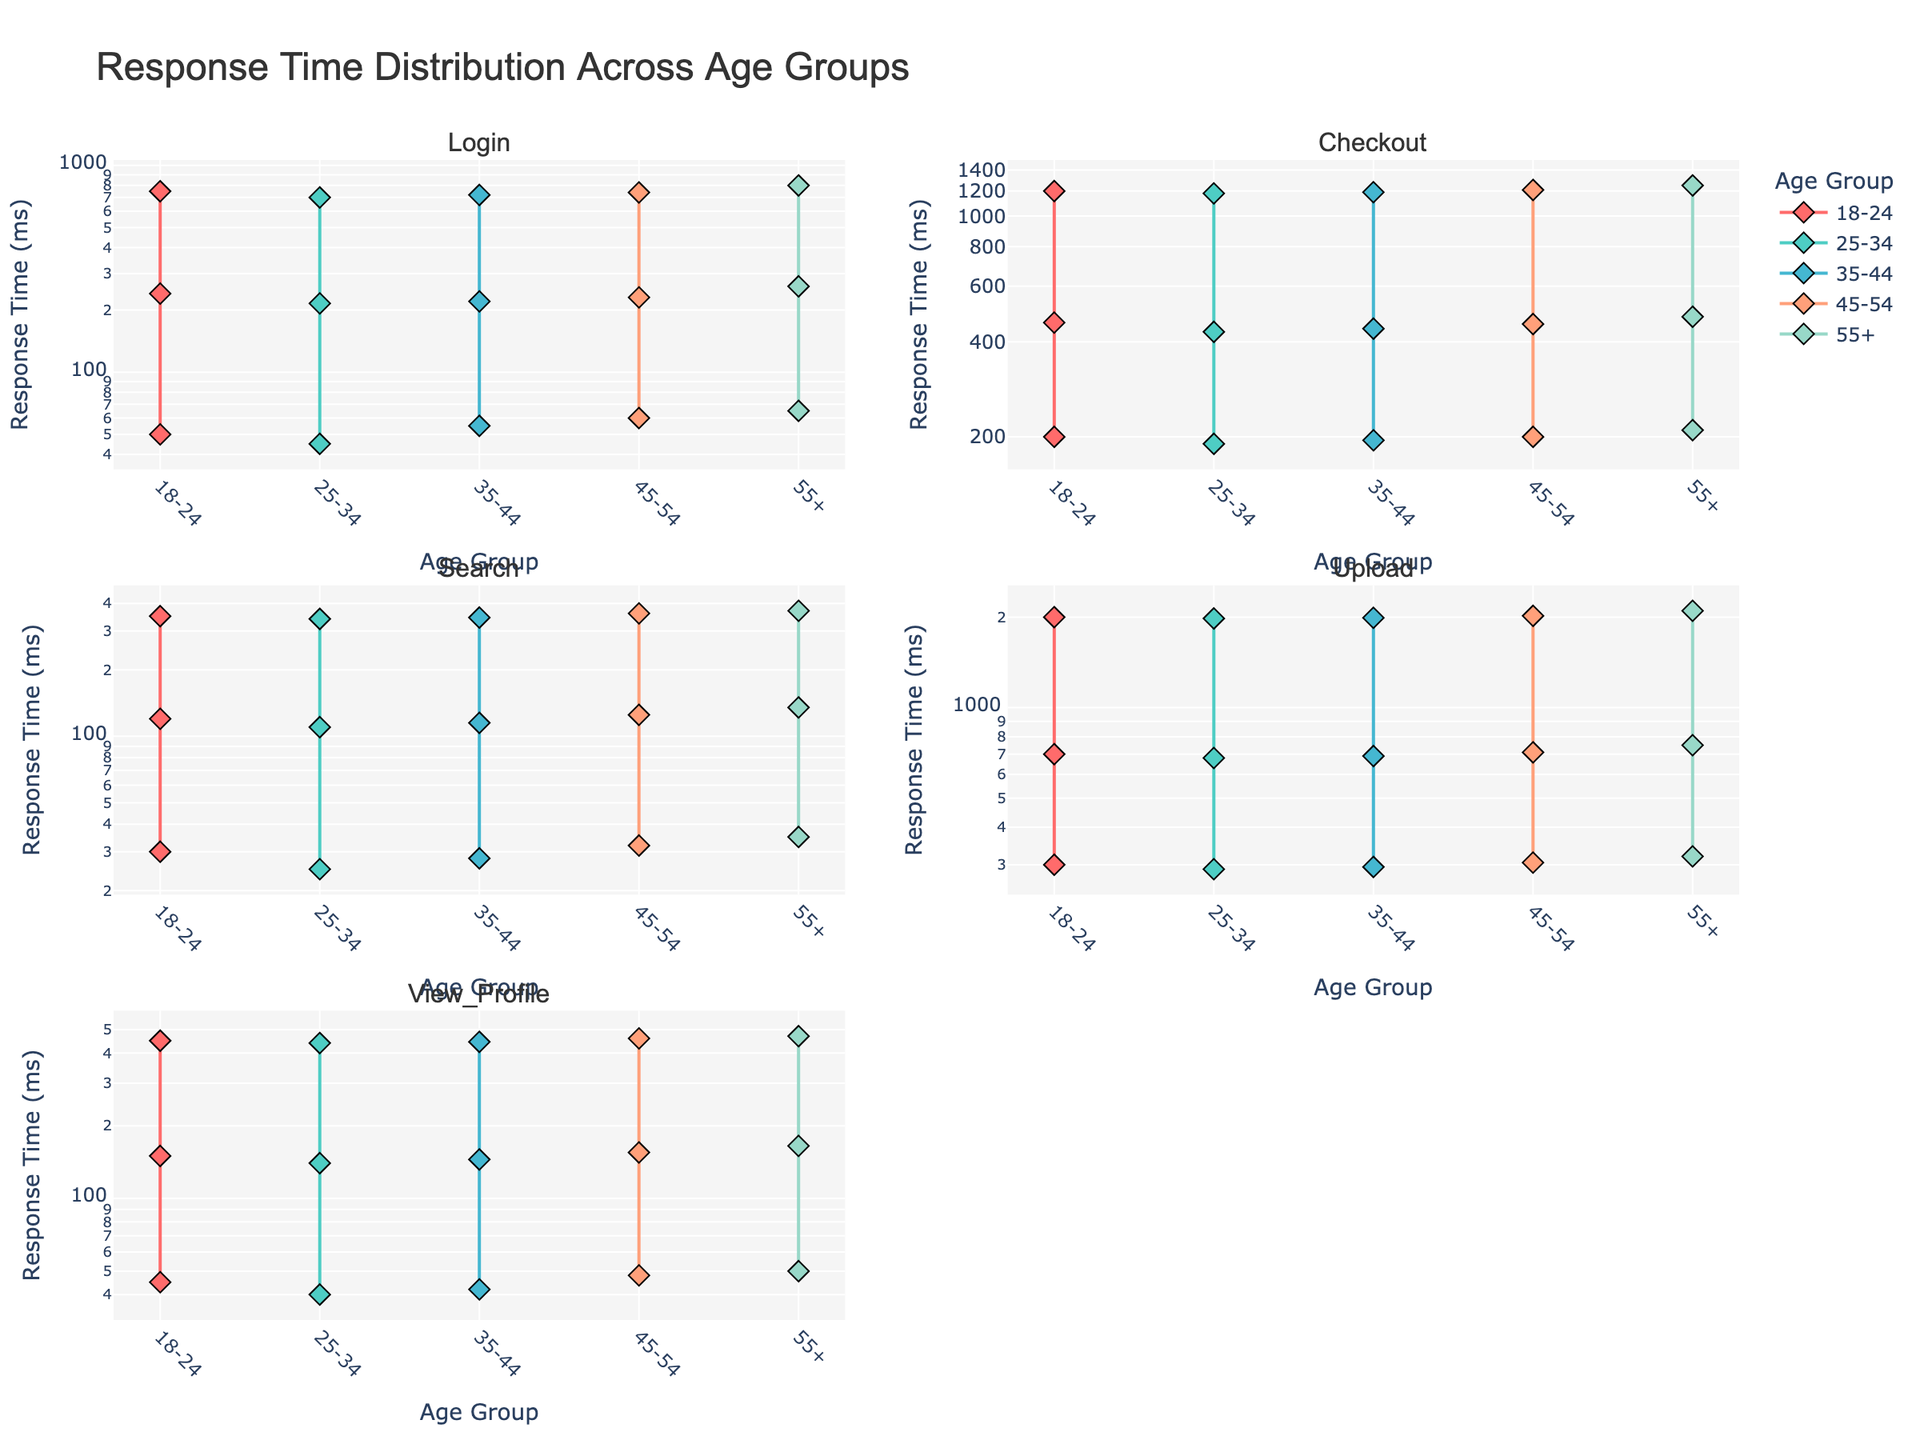What's the title of the figure? The figure's title is located at the top center and is written in a large font.
Answer: Response Time Distribution Across Age Groups How many subplots are there in the figure? The figure is divided into 3 rows and 2 columns, which amounts to 6 subplots in total.
Answer: Six Which functionality shows the highest mean response time in the '18-24' age group? In the subplot for 'Upload', the mean response time for the '18-24' age group is the highest, as indicated by a high point in the plot.
Answer: Upload Which age group has the lowest max response time for 'View_Profile' functionality? In the subplot for 'View_Profile', the '25-34' age group shows the lowest point for max response time among all age groups.
Answer: 25-34 Compare the mean response times for 'Search' functionality across the '18-24' and '55+' age groups. Which is higher? In the subplot for 'Search', the point representing the mean response time for '55+' is higher compared to '18-24'.
Answer: 55+ What’s the range of response times for 'Checkout' functionality in the '45-54' age group? In the subplot for 'Checkout', the '45-54' age group's response times range from the minimum (200 ms) to the maximum (1210 ms).
Answer: 200 ms to 1210 ms What is the average mean response time across the 'Login' functionality for all age groups? Calculate the mean response times for 'Login' and average them: (240 + 215 + 220 + 230 + 260) / 5 = 233 ms.
Answer: 233 ms Is the 'Upload' functionality consistently taking more time across all age groups compared to 'Search'? By comparing the logs across subplots, 'Upload' functionality shows consistently higher times across all age groups compared to 'Search'.
Answer: Yes Which functionality shows the most significant increase in max response time from the '25-34' to '55+' age groups? The 'Upload' functionality shows the most significant increase from around 1980 ms to 2100 ms as per the plot comparing max response times from '25-34' to '55+'.
Answer: Upload 